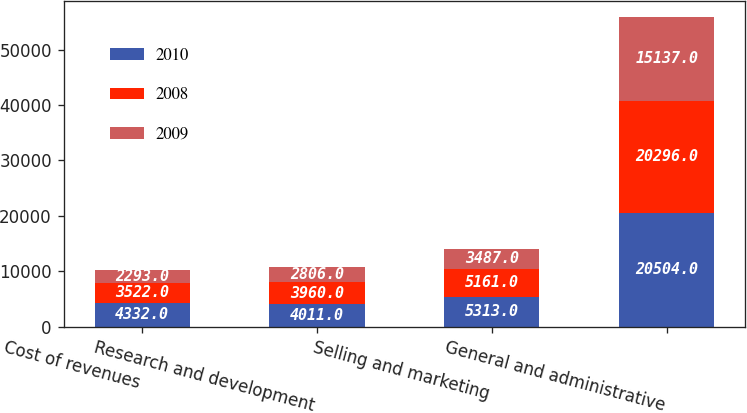Convert chart to OTSL. <chart><loc_0><loc_0><loc_500><loc_500><stacked_bar_chart><ecel><fcel>Cost of revenues<fcel>Research and development<fcel>Selling and marketing<fcel>General and administrative<nl><fcel>2010<fcel>4332<fcel>4011<fcel>5313<fcel>20504<nl><fcel>2008<fcel>3522<fcel>3960<fcel>5161<fcel>20296<nl><fcel>2009<fcel>2293<fcel>2806<fcel>3487<fcel>15137<nl></chart> 